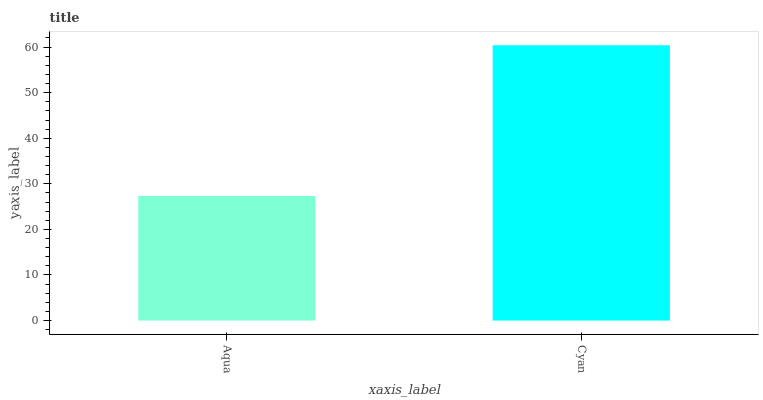Is Aqua the minimum?
Answer yes or no. Yes. Is Cyan the maximum?
Answer yes or no. Yes. Is Cyan the minimum?
Answer yes or no. No. Is Cyan greater than Aqua?
Answer yes or no. Yes. Is Aqua less than Cyan?
Answer yes or no. Yes. Is Aqua greater than Cyan?
Answer yes or no. No. Is Cyan less than Aqua?
Answer yes or no. No. Is Cyan the high median?
Answer yes or no. Yes. Is Aqua the low median?
Answer yes or no. Yes. Is Aqua the high median?
Answer yes or no. No. Is Cyan the low median?
Answer yes or no. No. 